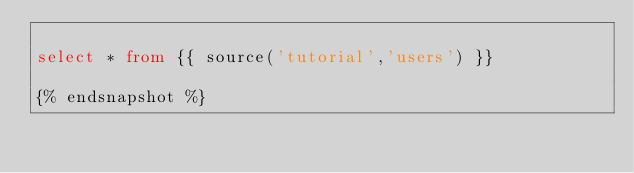<code> <loc_0><loc_0><loc_500><loc_500><_SQL_>
select * from {{ source('tutorial','users') }}

{% endsnapshot %}</code> 